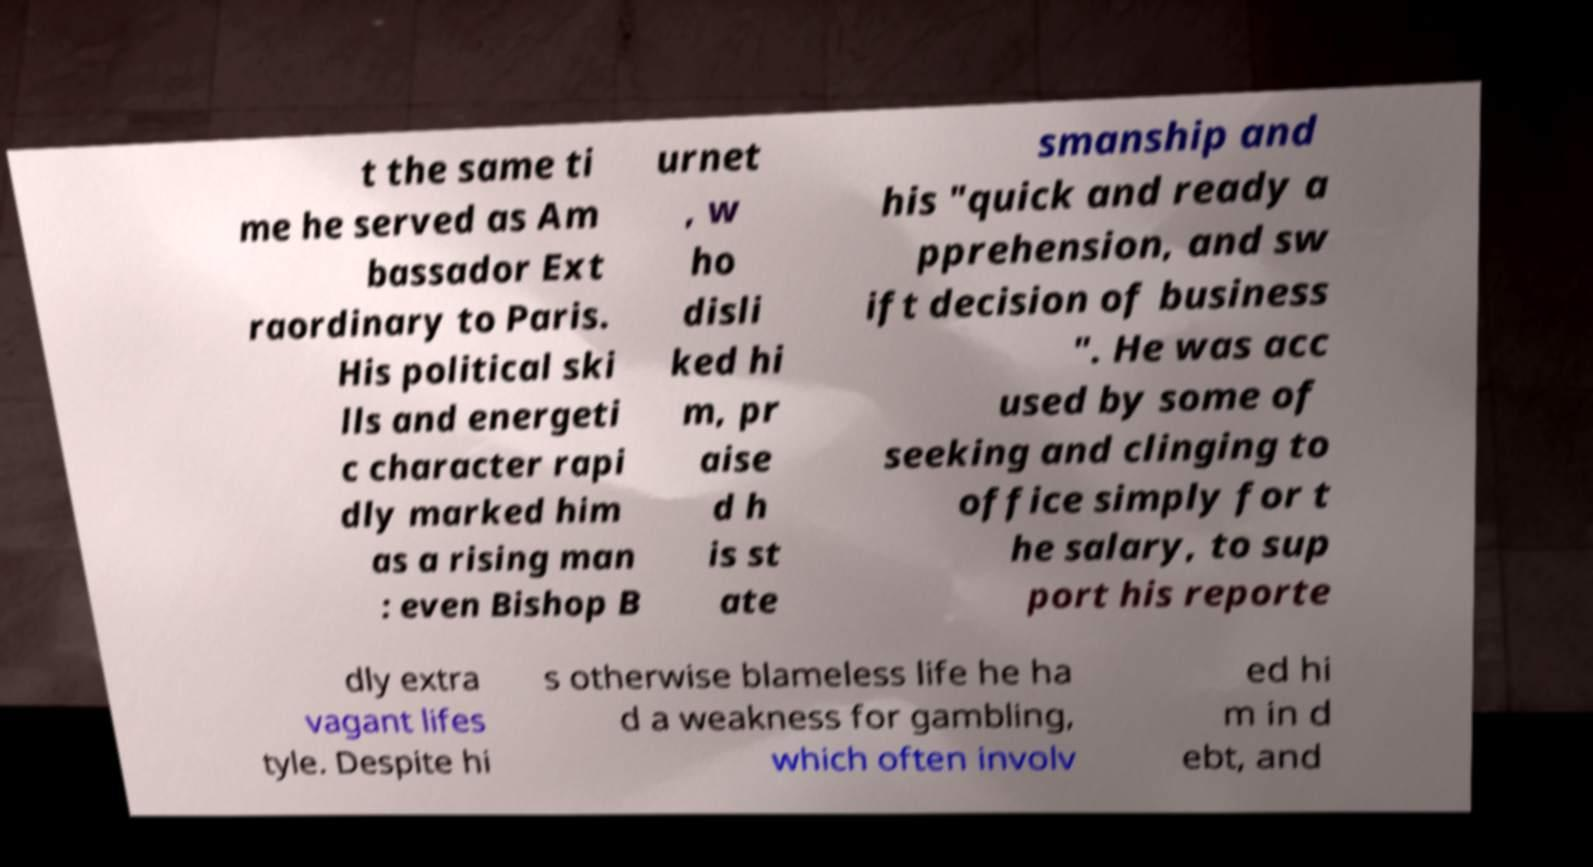Please read and relay the text visible in this image. What does it say? t the same ti me he served as Am bassador Ext raordinary to Paris. His political ski lls and energeti c character rapi dly marked him as a rising man : even Bishop B urnet , w ho disli ked hi m, pr aise d h is st ate smanship and his "quick and ready a pprehension, and sw ift decision of business ". He was acc used by some of seeking and clinging to office simply for t he salary, to sup port his reporte dly extra vagant lifes tyle. Despite hi s otherwise blameless life he ha d a weakness for gambling, which often involv ed hi m in d ebt, and 